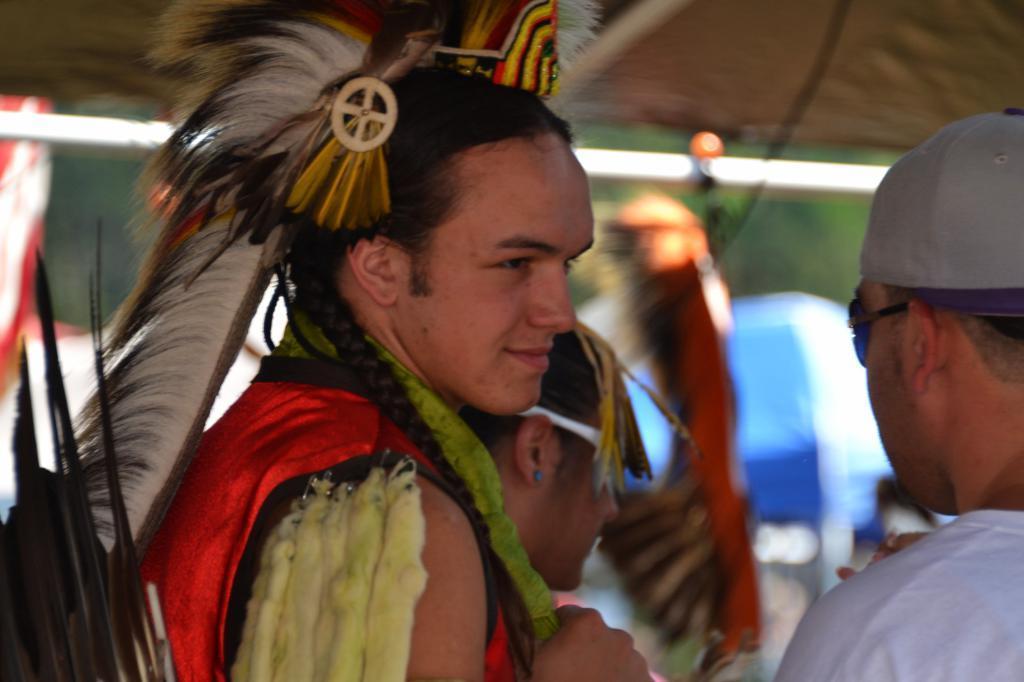In one or two sentences, can you explain what this image depicts? In the front of the image there are people and objects. In the background of the image it is blurry. 